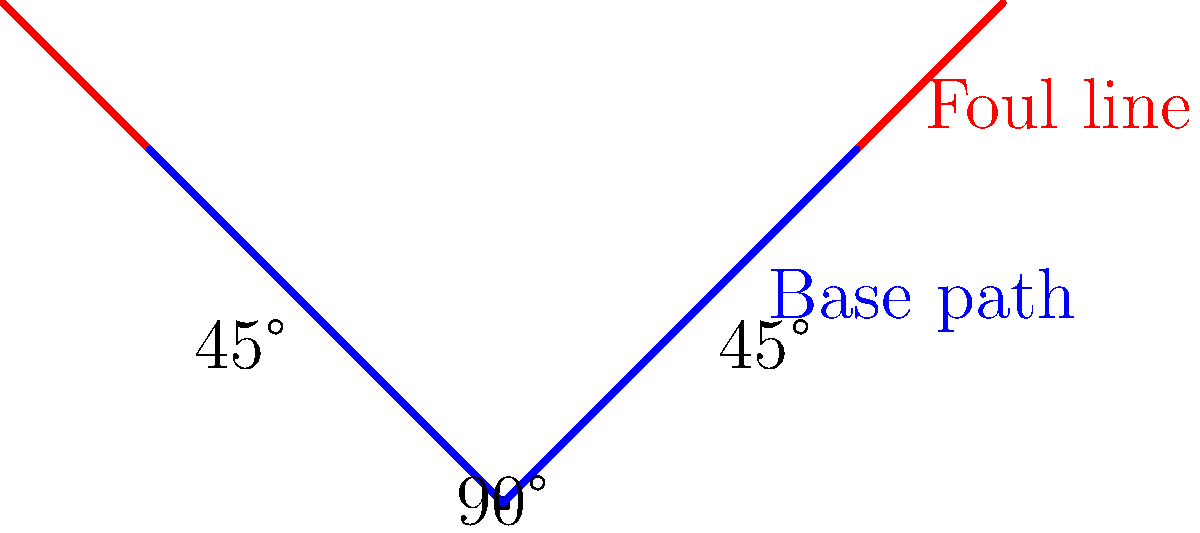In a standard baseball diamond, what is the angle between the foul line and the base path? To determine the angle between the foul line and the base path, let's follow these steps:

1. Recall that a standard baseball diamond is a square, with right angles (90°) at each base.

2. The foul lines extend from home plate through first and third base, forming two sides of the square. These lines create a 90° angle at home plate.

3. The base paths connect the bases, forming the sides of the square.

4. Since the diamond is a square, we can divide it into two equal right triangles by drawing a line from home plate to second base.

5. In each of these right triangles:
   - The hypotenuse is the foul line
   - One leg is the base path
   - The other leg is half of the line from first to third base

6. In a right triangle, the sum of the other two angles must be 90° (since 90° + 45° + 45° = 180°).

7. Given the symmetry of the diamond, these two angles must be equal. Therefore, each must be 45°.

8. Thus, the angle between the foul line (hypotenuse) and the base path (leg) is 45°.
Answer: 45° 